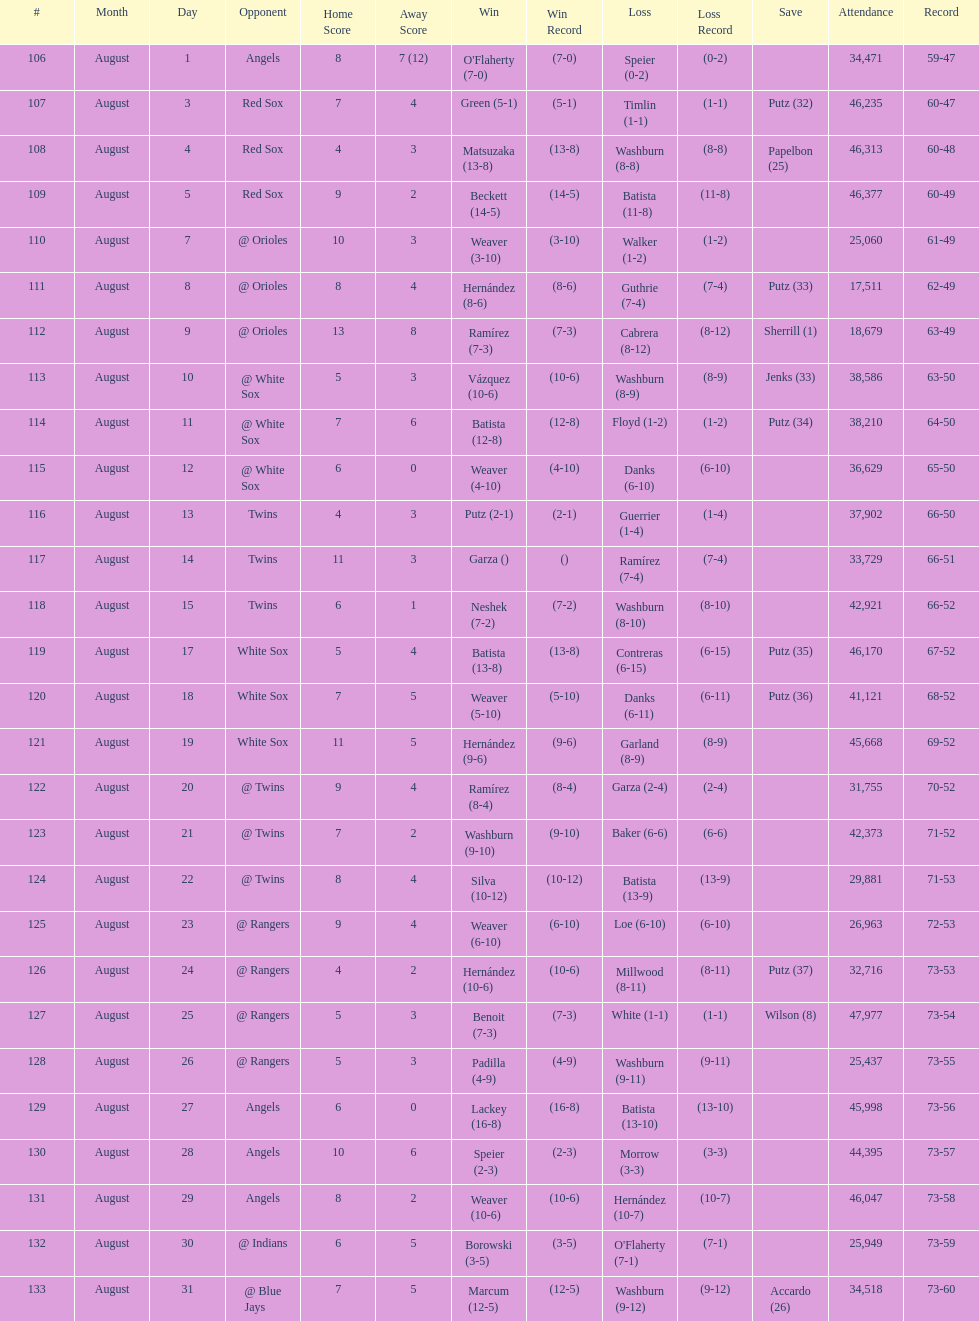Largest run differential 8. 